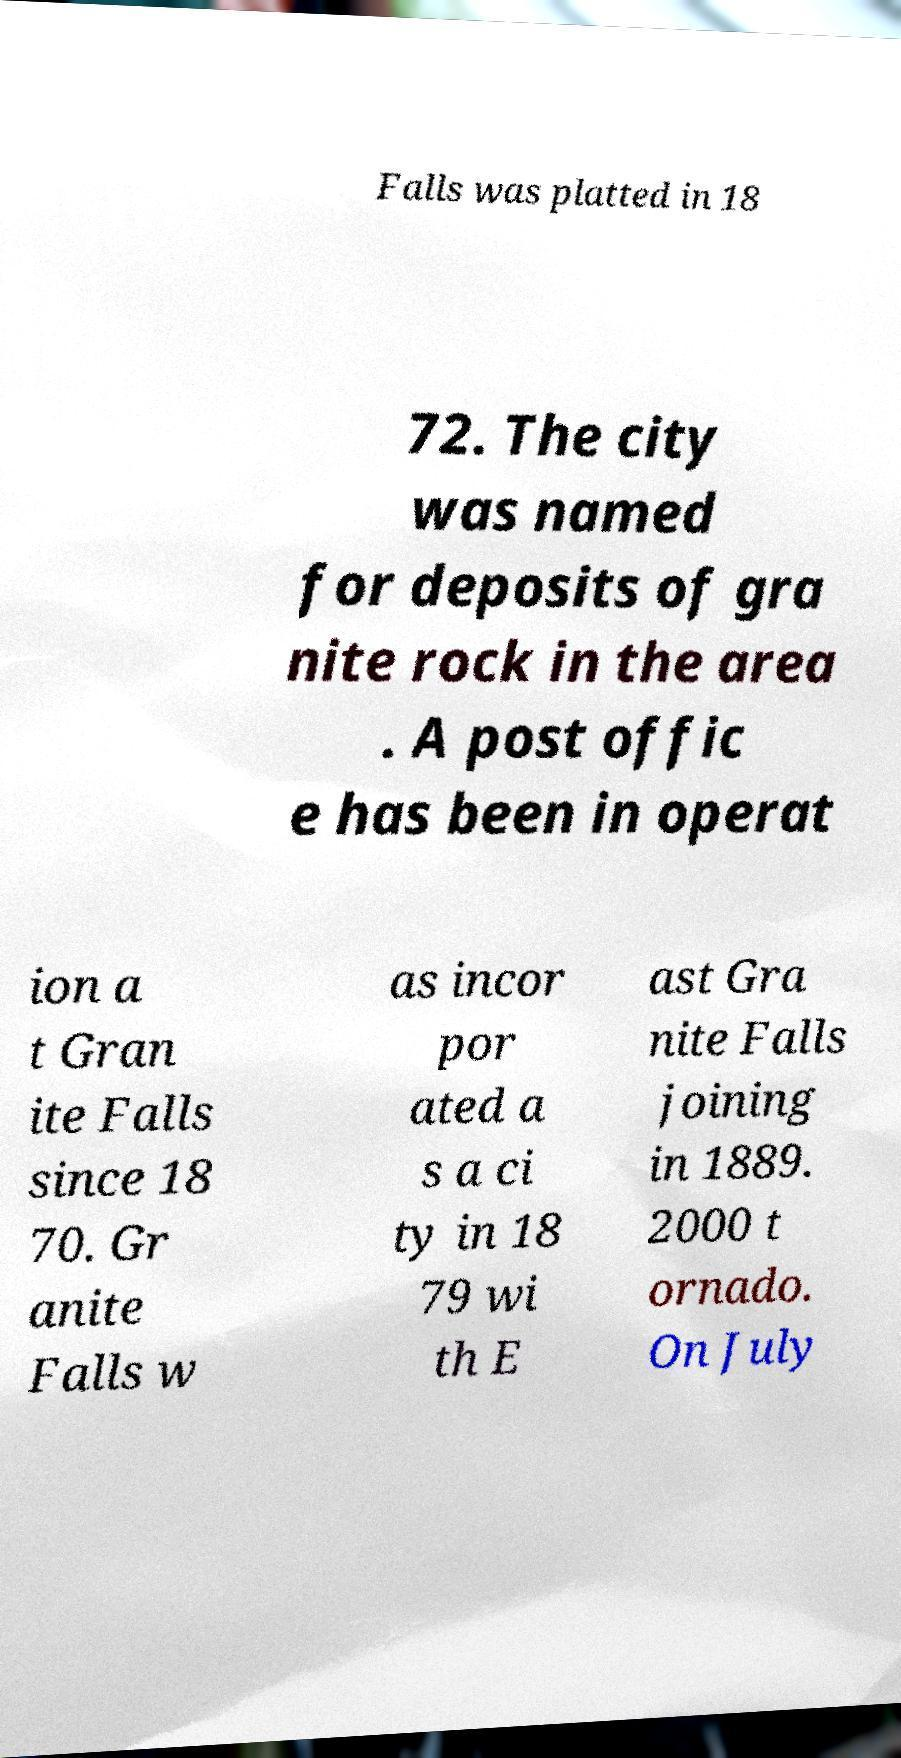What messages or text are displayed in this image? I need them in a readable, typed format. Falls was platted in 18 72. The city was named for deposits of gra nite rock in the area . A post offic e has been in operat ion a t Gran ite Falls since 18 70. Gr anite Falls w as incor por ated a s a ci ty in 18 79 wi th E ast Gra nite Falls joining in 1889. 2000 t ornado. On July 